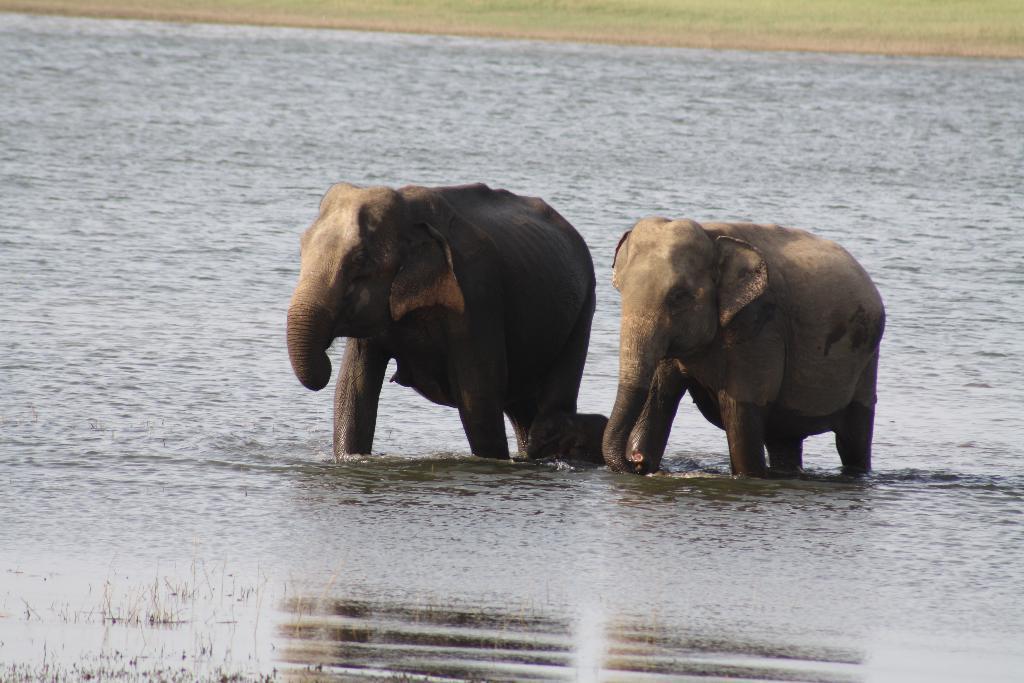Could you give a brief overview of what you see in this image? In this picture I can see the water and I see 3 elephants in the center of this image. In the background I see the grass. 